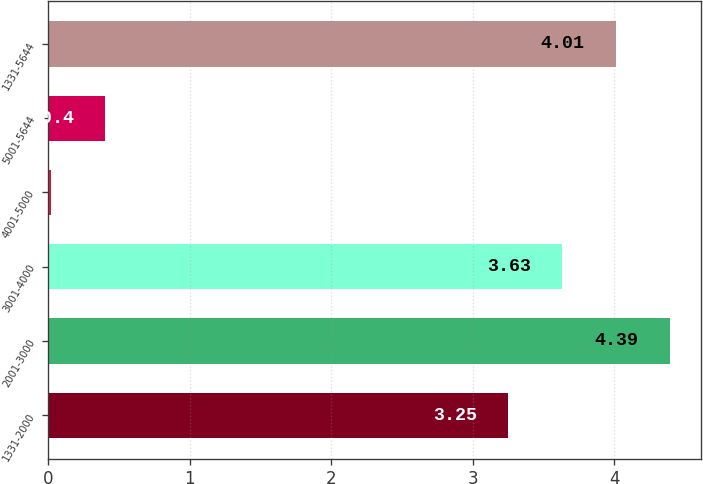Convert chart to OTSL. <chart><loc_0><loc_0><loc_500><loc_500><bar_chart><fcel>1331-2000<fcel>2001-3000<fcel>3001-4000<fcel>4001-5000<fcel>5001-5644<fcel>1331-5644<nl><fcel>3.25<fcel>4.39<fcel>3.63<fcel>0.02<fcel>0.4<fcel>4.01<nl></chart> 